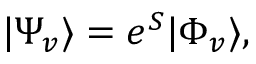Convert formula to latex. <formula><loc_0><loc_0><loc_500><loc_500>\begin{array} { r } { | \Psi _ { v } \rangle = e ^ { S } | \Phi _ { v } \rangle , } \end{array}</formula> 